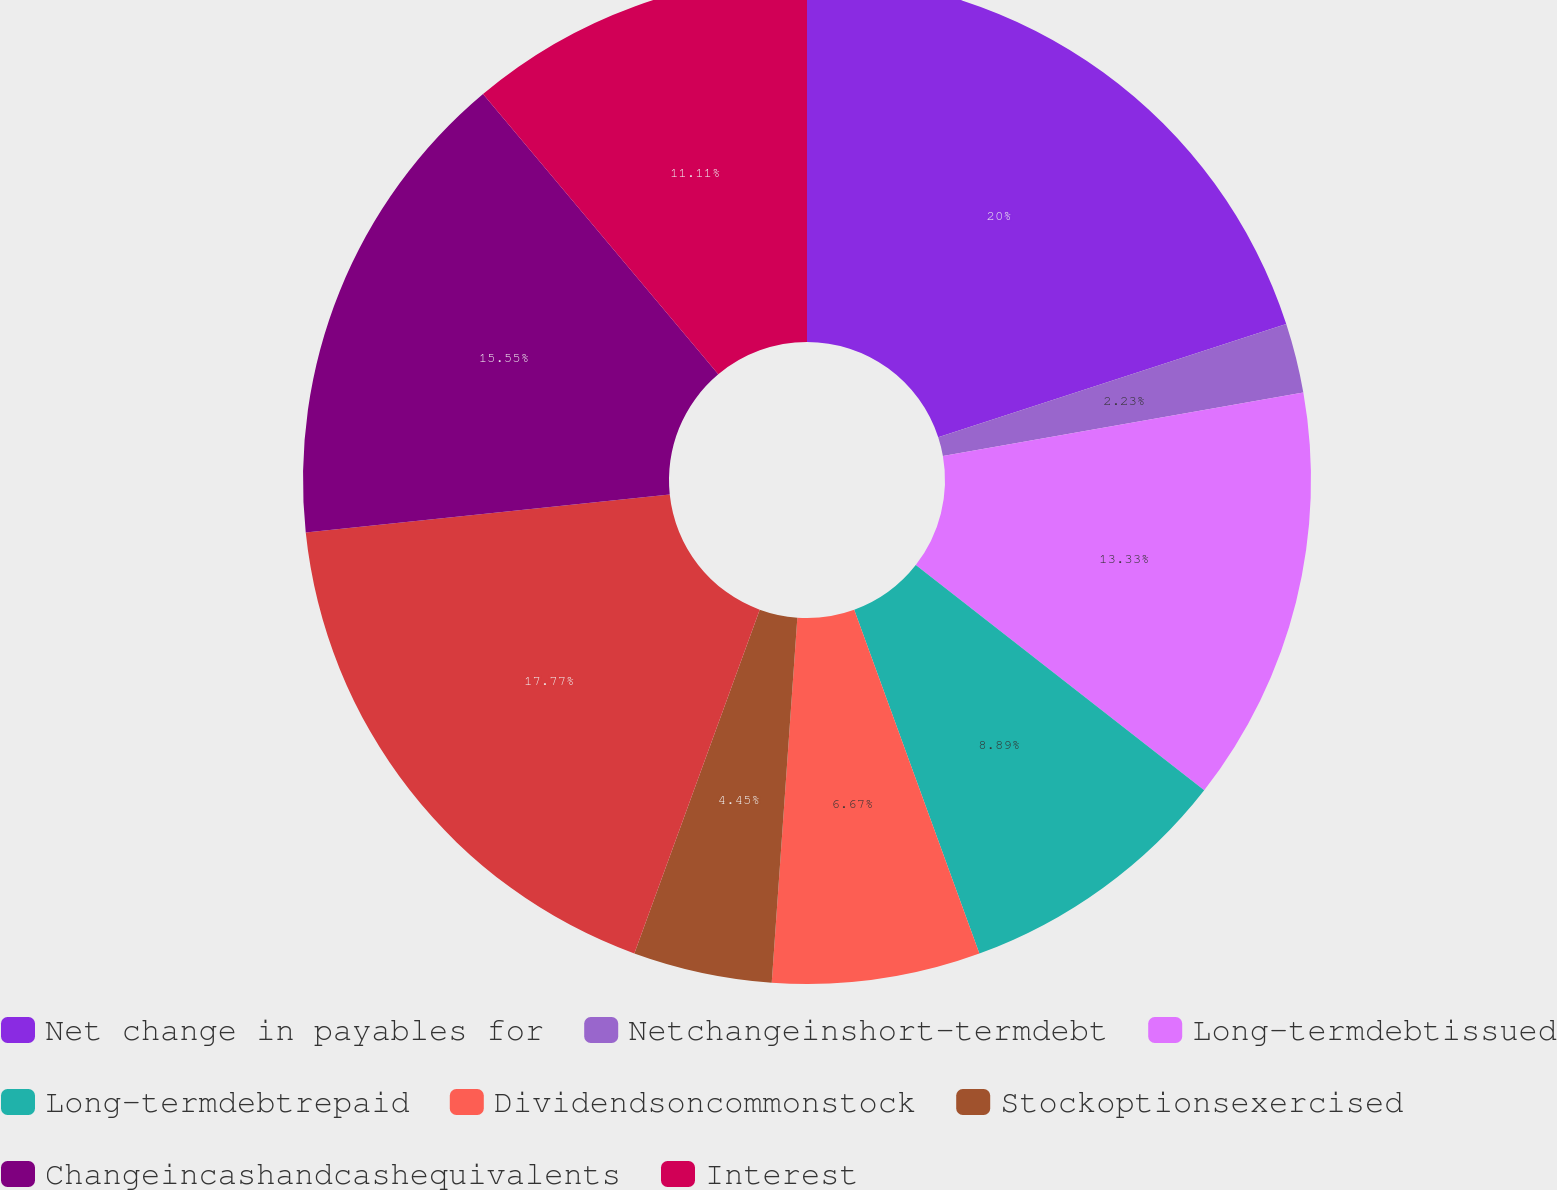<chart> <loc_0><loc_0><loc_500><loc_500><pie_chart><fcel>Net change in payables for<fcel>Netchangeinshort-termdebt<fcel>Long-termdebtissued<fcel>Long-termdebtrepaid<fcel>Dividendsoncommonstock<fcel>Stockoptionsexercised<fcel>Unnamed: 6<fcel>Changeincashandcashequivalents<fcel>Interest<nl><fcel>19.99%<fcel>2.23%<fcel>13.33%<fcel>8.89%<fcel>6.67%<fcel>4.45%<fcel>17.77%<fcel>15.55%<fcel>11.11%<nl></chart> 